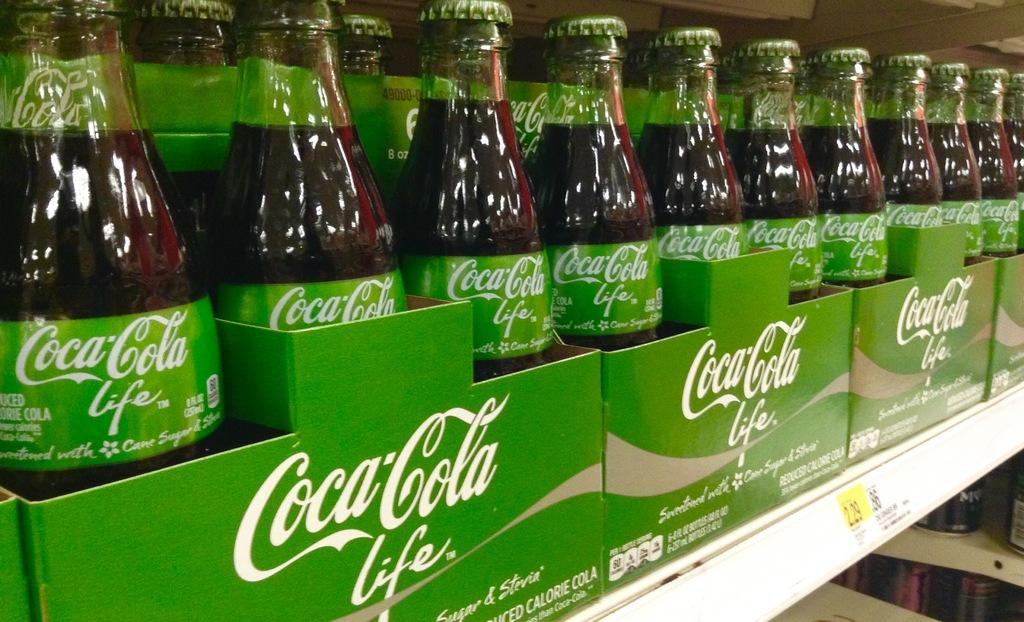What objects are present in the image? There are bottles in the image. How are the bottles arranged or organized? The bottles are in boxes. What type of stew is being prepared in the image? There is no stew present in the image; it only features bottles in boxes. 